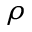<formula> <loc_0><loc_0><loc_500><loc_500>\rho</formula> 